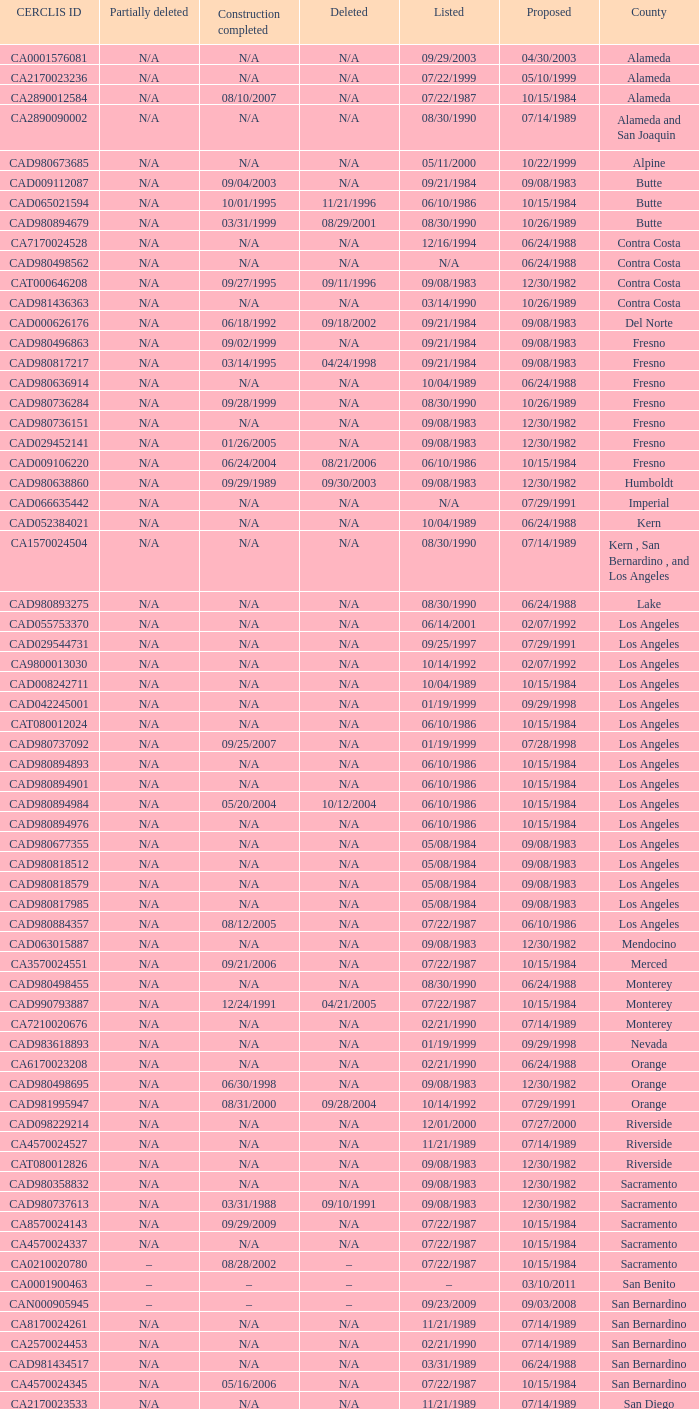What construction completed on 08/10/2007? 07/22/1987. 